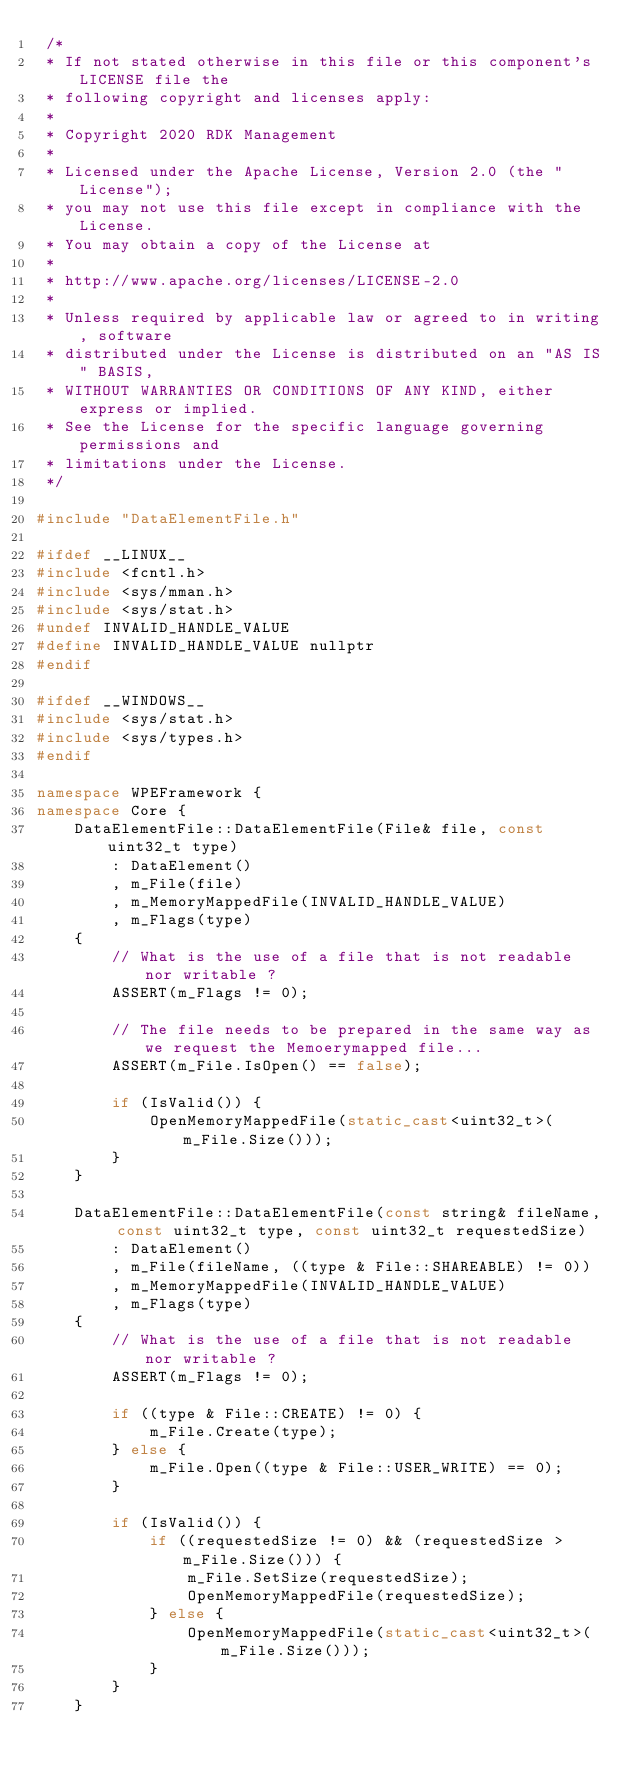<code> <loc_0><loc_0><loc_500><loc_500><_C++_> /*
 * If not stated otherwise in this file or this component's LICENSE file the
 * following copyright and licenses apply:
 *
 * Copyright 2020 RDK Management
 *
 * Licensed under the Apache License, Version 2.0 (the "License");
 * you may not use this file except in compliance with the License.
 * You may obtain a copy of the License at
 *
 * http://www.apache.org/licenses/LICENSE-2.0
 *
 * Unless required by applicable law or agreed to in writing, software
 * distributed under the License is distributed on an "AS IS" BASIS,
 * WITHOUT WARRANTIES OR CONDITIONS OF ANY KIND, either express or implied.
 * See the License for the specific language governing permissions and
 * limitations under the License.
 */

#include "DataElementFile.h"

#ifdef __LINUX__
#include <fcntl.h>
#include <sys/mman.h>
#include <sys/stat.h>
#undef INVALID_HANDLE_VALUE
#define INVALID_HANDLE_VALUE nullptr
#endif

#ifdef __WINDOWS__
#include <sys/stat.h>
#include <sys/types.h>
#endif

namespace WPEFramework {
namespace Core {
    DataElementFile::DataElementFile(File& file, const uint32_t type)
        : DataElement()
        , m_File(file)
        , m_MemoryMappedFile(INVALID_HANDLE_VALUE)
        , m_Flags(type)
    {
        // What is the use of a file that is not readable nor writable ?
        ASSERT(m_Flags != 0);

        // The file needs to be prepared in the same way as we request the Memoerymapped file...
        ASSERT(m_File.IsOpen() == false);

        if (IsValid()) {
            OpenMemoryMappedFile(static_cast<uint32_t>(m_File.Size()));
        }
    }

    DataElementFile::DataElementFile(const string& fileName, const uint32_t type, const uint32_t requestedSize)
        : DataElement()
        , m_File(fileName, ((type & File::SHAREABLE) != 0))
        , m_MemoryMappedFile(INVALID_HANDLE_VALUE)
        , m_Flags(type)
    {
        // What is the use of a file that is not readable nor writable ?
        ASSERT(m_Flags != 0);

        if ((type & File::CREATE) != 0) {
            m_File.Create(type);
        } else {
            m_File.Open((type & File::USER_WRITE) == 0);
        }

        if (IsValid()) {
            if ((requestedSize != 0) && (requestedSize > m_File.Size())) {
                m_File.SetSize(requestedSize);
                OpenMemoryMappedFile(requestedSize);
            } else {
                OpenMemoryMappedFile(static_cast<uint32_t>(m_File.Size()));
            }
        }
    }
</code> 